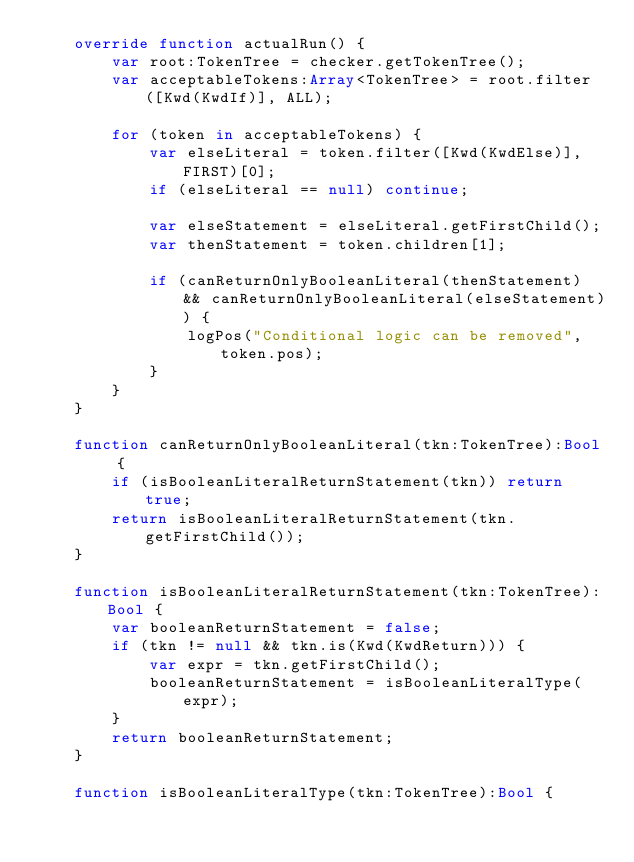Convert code to text. <code><loc_0><loc_0><loc_500><loc_500><_Haxe_>	override function actualRun() {
		var root:TokenTree = checker.getTokenTree();
		var acceptableTokens:Array<TokenTree> = root.filter([Kwd(KwdIf)], ALL);

		for (token in acceptableTokens) {
			var elseLiteral = token.filter([Kwd(KwdElse)], FIRST)[0];
			if (elseLiteral == null) continue;

			var elseStatement = elseLiteral.getFirstChild();
			var thenStatement = token.children[1];

			if (canReturnOnlyBooleanLiteral(thenStatement) && canReturnOnlyBooleanLiteral(elseStatement)) {
				logPos("Conditional logic can be removed", token.pos);
			}
		}
	}

	function canReturnOnlyBooleanLiteral(tkn:TokenTree):Bool {
		if (isBooleanLiteralReturnStatement(tkn)) return true;
		return isBooleanLiteralReturnStatement(tkn.getFirstChild());
	}

	function isBooleanLiteralReturnStatement(tkn:TokenTree):Bool {
		var booleanReturnStatement = false;
		if (tkn != null && tkn.is(Kwd(KwdReturn))) {
			var expr = tkn.getFirstChild();
			booleanReturnStatement = isBooleanLiteralType(expr);
		}
		return booleanReturnStatement;
	}

	function isBooleanLiteralType(tkn:TokenTree):Bool {</code> 